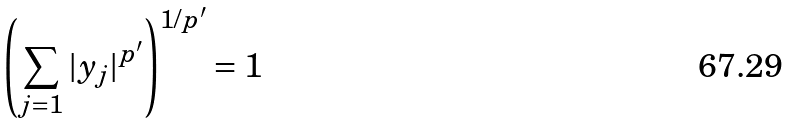<formula> <loc_0><loc_0><loc_500><loc_500>\left ( \sum _ { j = 1 } | y _ { j } | ^ { p ^ { \prime } } \right ) ^ { 1 / p ^ { \prime } } = 1</formula> 